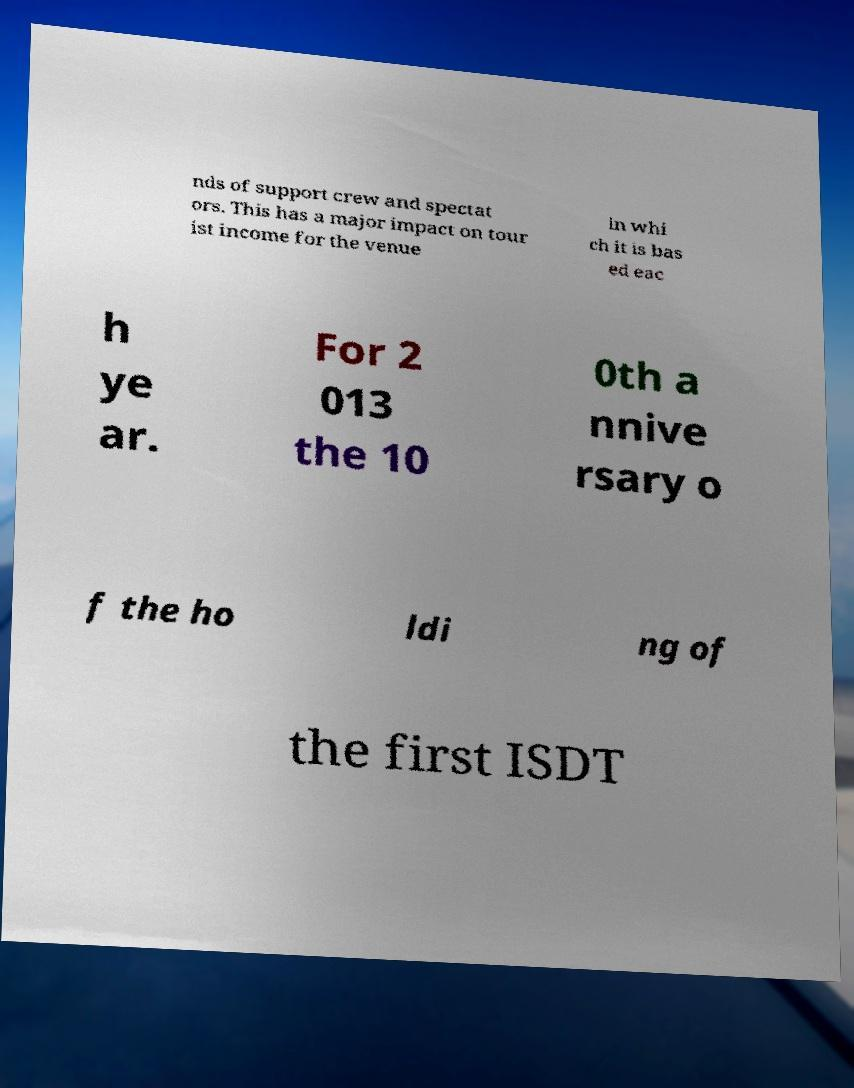Can you read and provide the text displayed in the image?This photo seems to have some interesting text. Can you extract and type it out for me? nds of support crew and spectat ors. This has a major impact on tour ist income for the venue in whi ch it is bas ed eac h ye ar. For 2 013 the 10 0th a nnive rsary o f the ho ldi ng of the first ISDT 